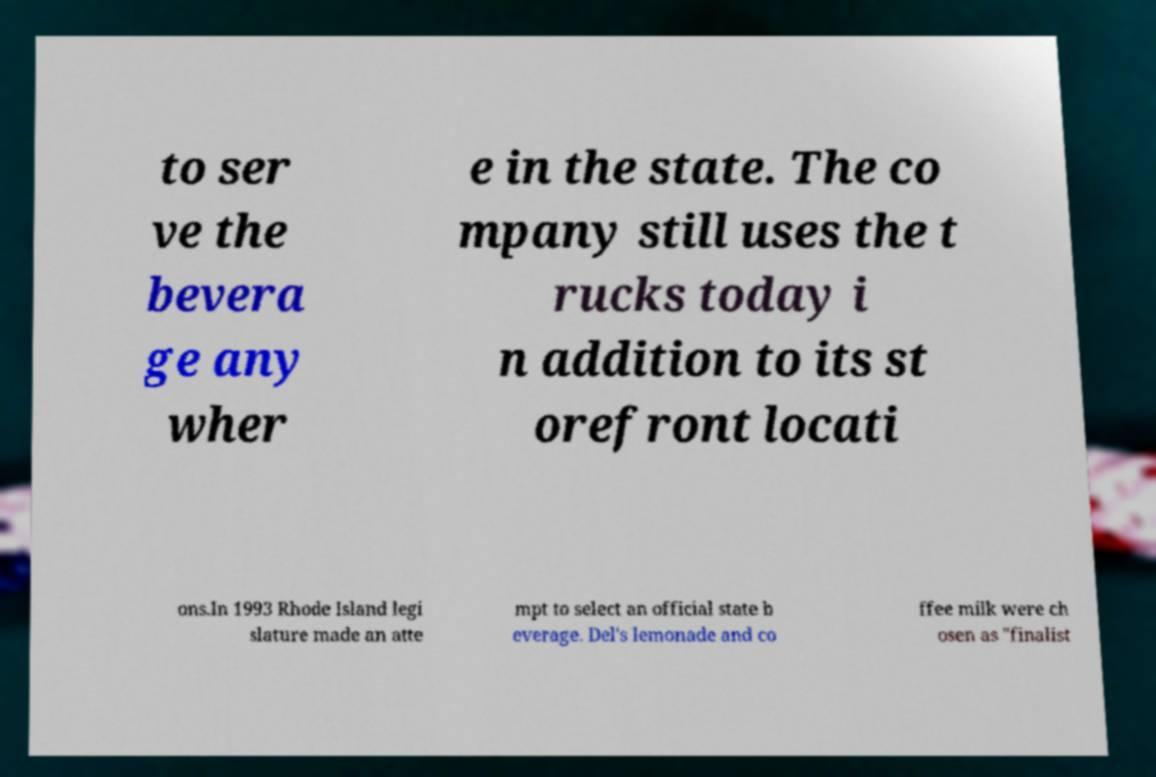Can you read and provide the text displayed in the image?This photo seems to have some interesting text. Can you extract and type it out for me? to ser ve the bevera ge any wher e in the state. The co mpany still uses the t rucks today i n addition to its st orefront locati ons.In 1993 Rhode Island legi slature made an atte mpt to select an official state b everage. Del's lemonade and co ffee milk were ch osen as "finalist 